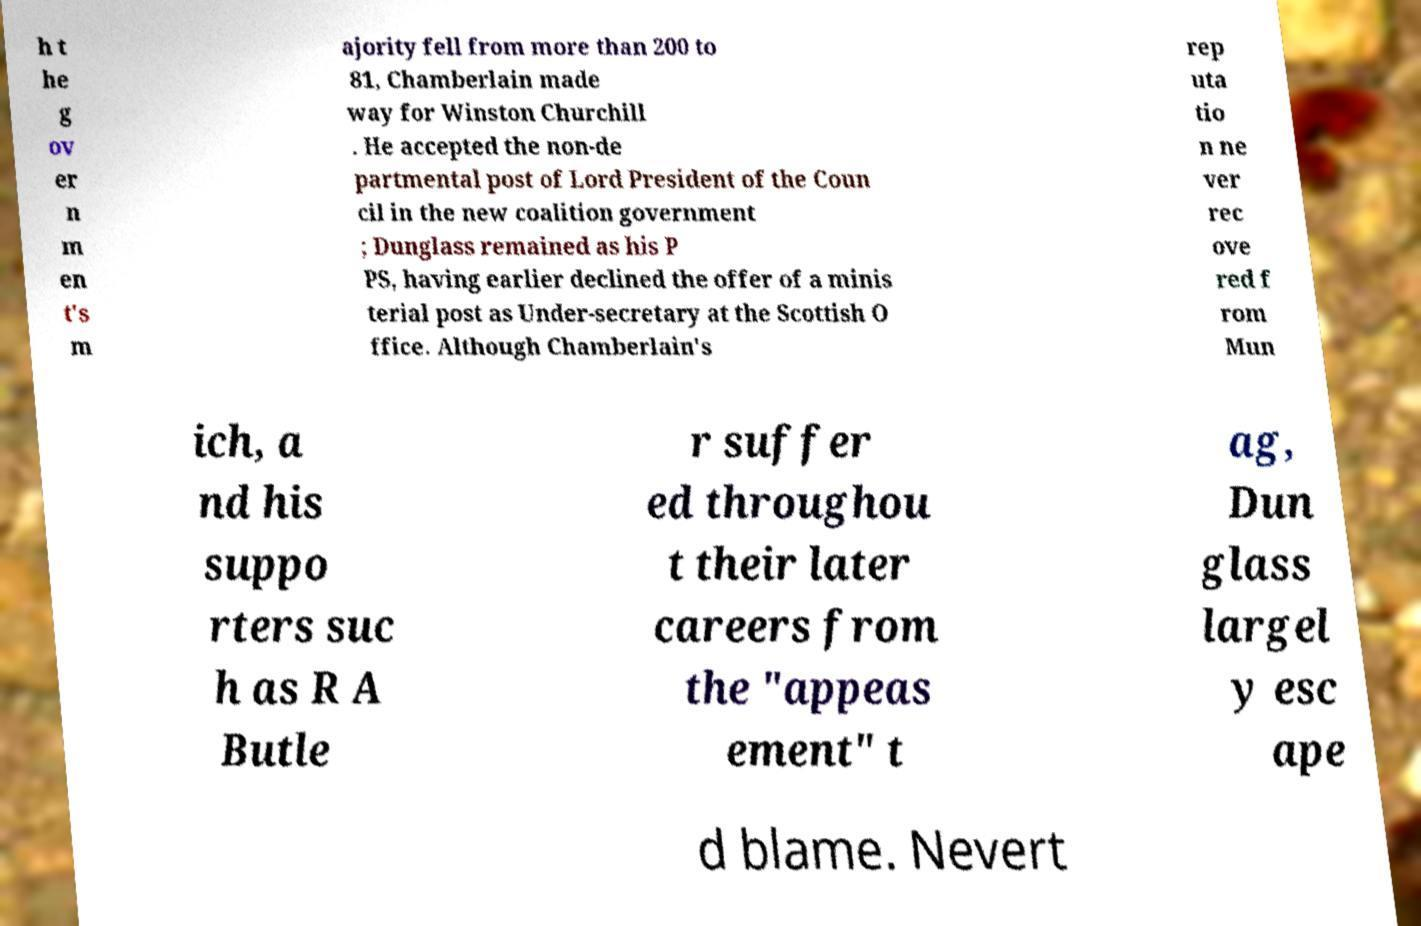There's text embedded in this image that I need extracted. Can you transcribe it verbatim? h t he g ov er n m en t's m ajority fell from more than 200 to 81, Chamberlain made way for Winston Churchill . He accepted the non-de partmental post of Lord President of the Coun cil in the new coalition government ; Dunglass remained as his P PS, having earlier declined the offer of a minis terial post as Under-secretary at the Scottish O ffice. Although Chamberlain's rep uta tio n ne ver rec ove red f rom Mun ich, a nd his suppo rters suc h as R A Butle r suffer ed throughou t their later careers from the "appeas ement" t ag, Dun glass largel y esc ape d blame. Nevert 